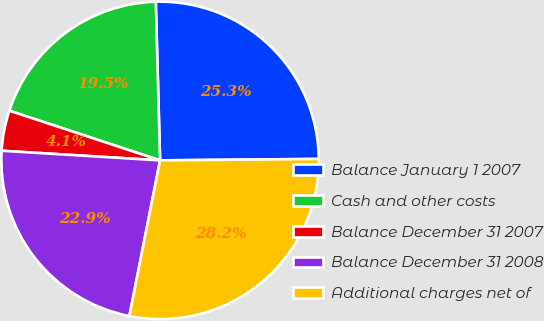Convert chart. <chart><loc_0><loc_0><loc_500><loc_500><pie_chart><fcel>Balance January 1 2007<fcel>Cash and other costs<fcel>Balance December 31 2007<fcel>Balance December 31 2008<fcel>Additional charges net of<nl><fcel>25.29%<fcel>19.5%<fcel>4.1%<fcel>22.87%<fcel>28.24%<nl></chart> 